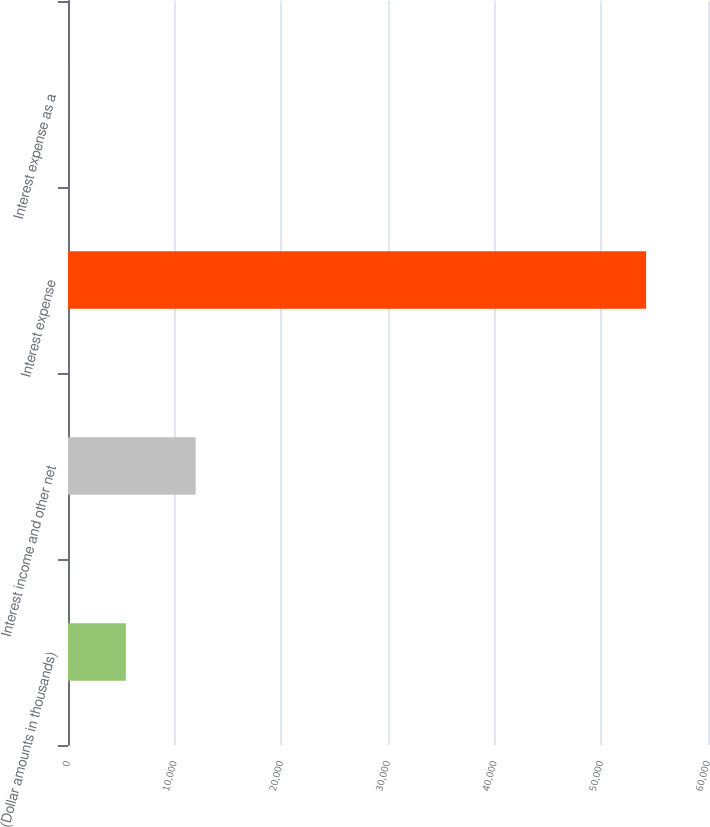<chart> <loc_0><loc_0><loc_500><loc_500><bar_chart><fcel>(Dollar amounts in thousands)<fcel>Interest income and other net<fcel>Interest expense<fcel>Interest expense as a<nl><fcel>5421.5<fcel>11966<fcel>54197<fcel>2<nl></chart> 